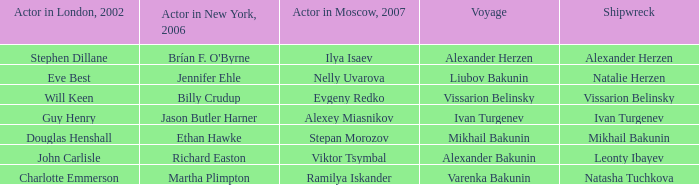Who was the actor in Moscow who did the part done by John Carlisle in London in 2002? Viktor Tsymbal. I'm looking to parse the entire table for insights. Could you assist me with that? {'header': ['Actor in London, 2002', 'Actor in New York, 2006', 'Actor in Moscow, 2007', 'Voyage', 'Shipwreck'], 'rows': [['Stephen Dillane', "Brían F. O'Byrne", 'Ilya Isaev', 'Alexander Herzen', 'Alexander Herzen'], ['Eve Best', 'Jennifer Ehle', 'Nelly Uvarova', 'Liubov Bakunin', 'Natalie Herzen'], ['Will Keen', 'Billy Crudup', 'Evgeny Redko', 'Vissarion Belinsky', 'Vissarion Belinsky'], ['Guy Henry', 'Jason Butler Harner', 'Alexey Miasnikov', 'Ivan Turgenev', 'Ivan Turgenev'], ['Douglas Henshall', 'Ethan Hawke', 'Stepan Morozov', 'Mikhail Bakunin', 'Mikhail Bakunin'], ['John Carlisle', 'Richard Easton', 'Viktor Tsymbal', 'Alexander Bakunin', 'Leonty Ibayev'], ['Charlotte Emmerson', 'Martha Plimpton', 'Ramilya Iskander', 'Varenka Bakunin', 'Natasha Tuchkova']]} 